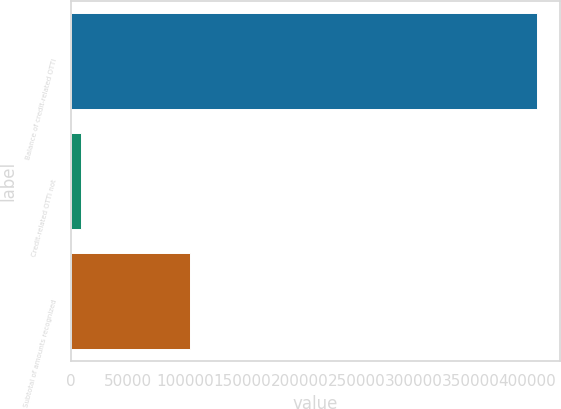<chart> <loc_0><loc_0><loc_500><loc_500><bar_chart><fcel>Balance of credit-related OTTI<fcel>Credit-related OTTI not<fcel>Subtotal of amounts recognized<nl><fcel>408043<fcel>8544<fcel>104061<nl></chart> 